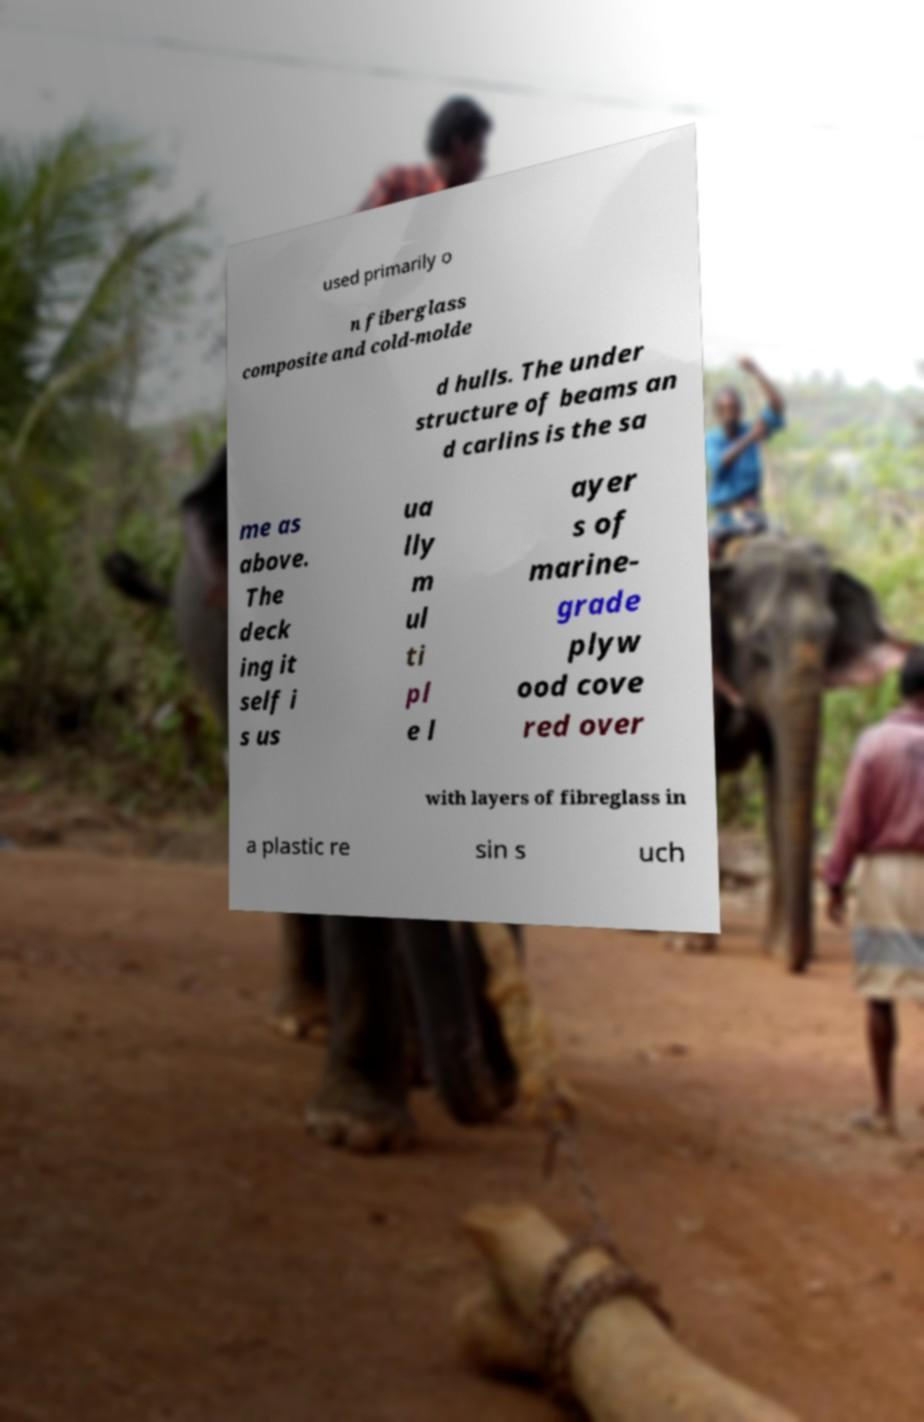I need the written content from this picture converted into text. Can you do that? used primarily o n fiberglass composite and cold-molde d hulls. The under structure of beams an d carlins is the sa me as above. The deck ing it self i s us ua lly m ul ti pl e l ayer s of marine- grade plyw ood cove red over with layers of fibreglass in a plastic re sin s uch 